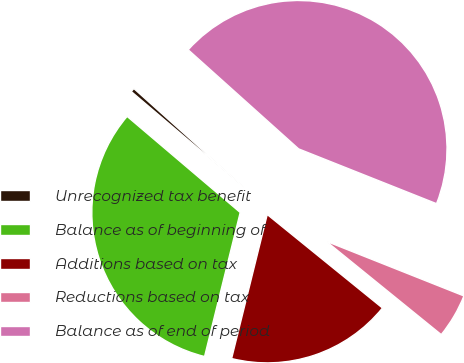Convert chart. <chart><loc_0><loc_0><loc_500><loc_500><pie_chart><fcel>Unrecognized tax benefit<fcel>Balance as of beginning of<fcel>Additions based on tax<fcel>Reductions based on tax<fcel>Balance as of end of period<nl><fcel>0.43%<fcel>32.35%<fcel>18.01%<fcel>4.83%<fcel>44.38%<nl></chart> 